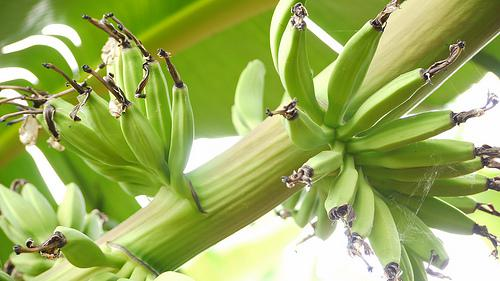Question: what is growing on the branch?
Choices:
A. Flowers.
B. Leaves.
C. Pine cones.
D. Pods.
Answer with the letter. Answer: D Question: what color are the pods?
Choices:
A. Orange.
B. Green and brown.
C. Yellow.
D. Blue.
Answer with the letter. Answer: B Question: who is in the picture?
Choices:
A. The child.
B. The dad.
C. The mom.
D. No one.
Answer with the letter. Answer: D 